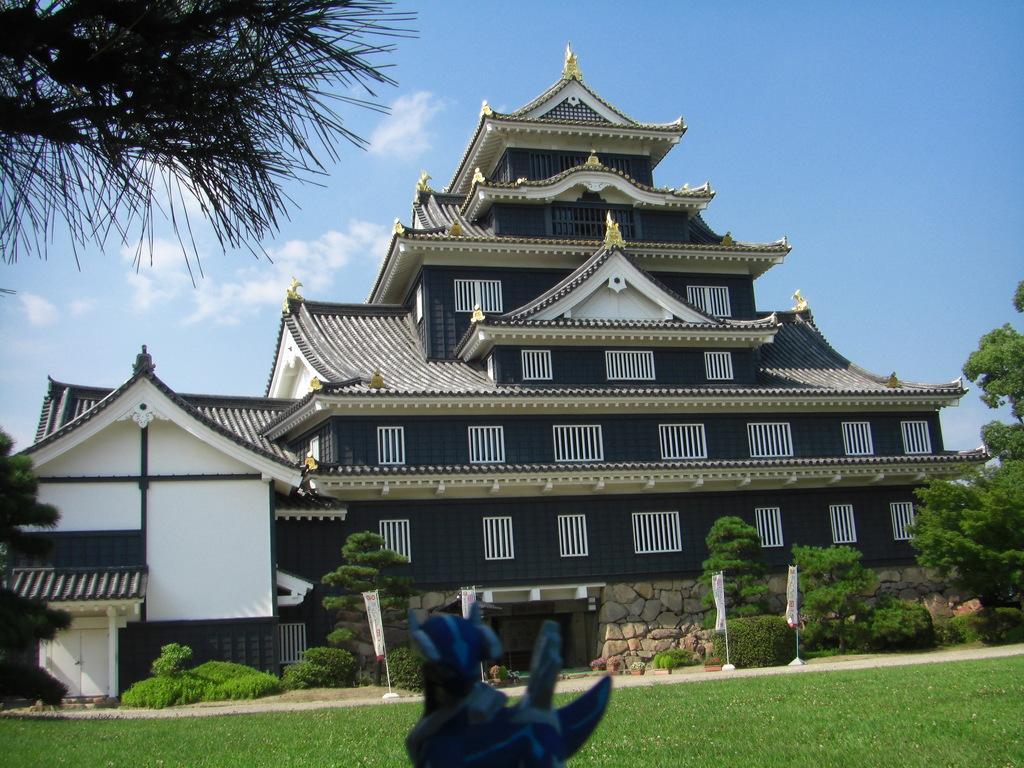Can you describe this image briefly? In the picture I can see the house and windows. There are trees on the left side and the right side as well. I can see the green grass at the bottom of the picture. There are clouds in the sky. These are looking like banner poles on the side of the green grass. 